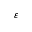Convert formula to latex. <formula><loc_0><loc_0><loc_500><loc_500>\varepsilon</formula> 